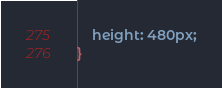<code> <loc_0><loc_0><loc_500><loc_500><_CSS_>    height: 480px;
}</code> 